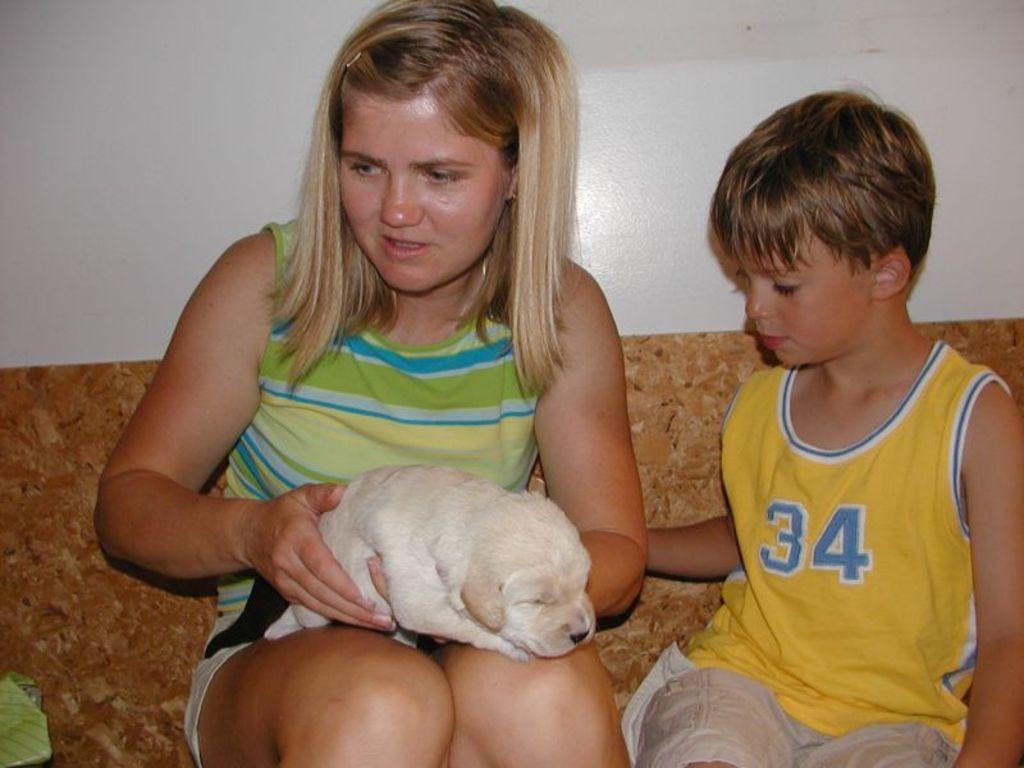How would you summarize this image in a sentence or two? In this image i can see a girl sit on the sofa set , holding a baby dog on her hand ,beside her a boy sat on the sofa set. 